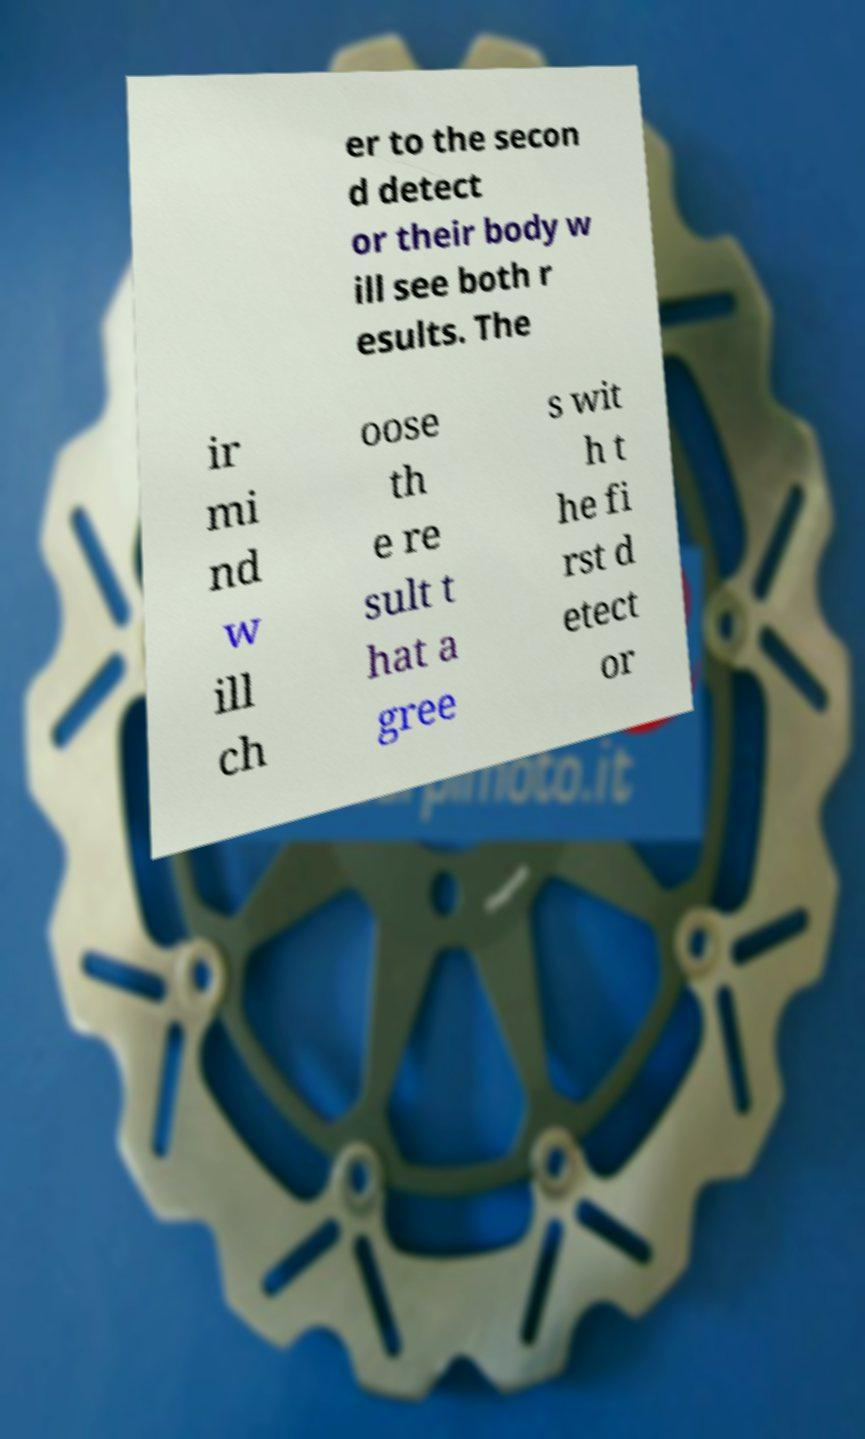Could you extract and type out the text from this image? er to the secon d detect or their body w ill see both r esults. The ir mi nd w ill ch oose th e re sult t hat a gree s wit h t he fi rst d etect or 